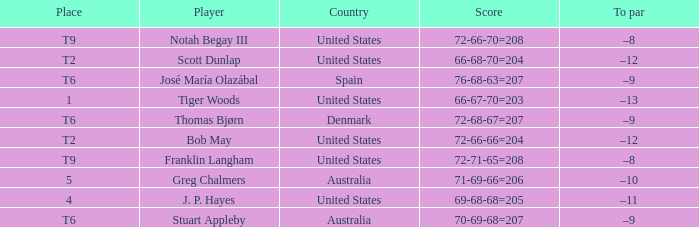What is the place of the player with a 66-68-70=204 score? T2. 